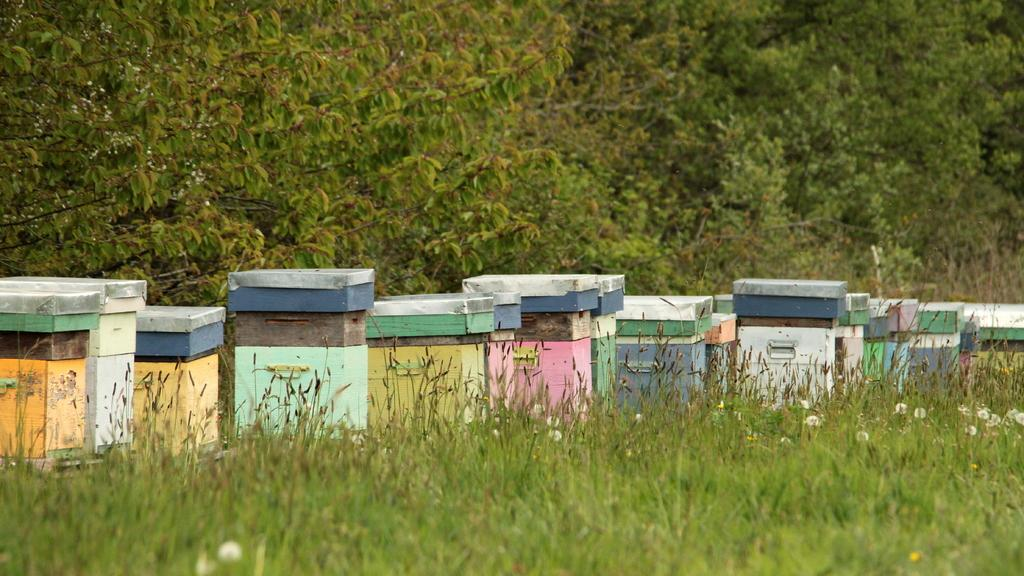What type of vegetation is present on the ground in the front of the image? There is grass on the ground in the front of the image. What can be seen in the center of the image? There are colorful objects in the center of the image. What is visible in the background of the image? There are trees in the background of the image. What type of waves can be seen in the image? There are no waves present in the image. What is the governor doing in the image? There is no governor present in the image. 